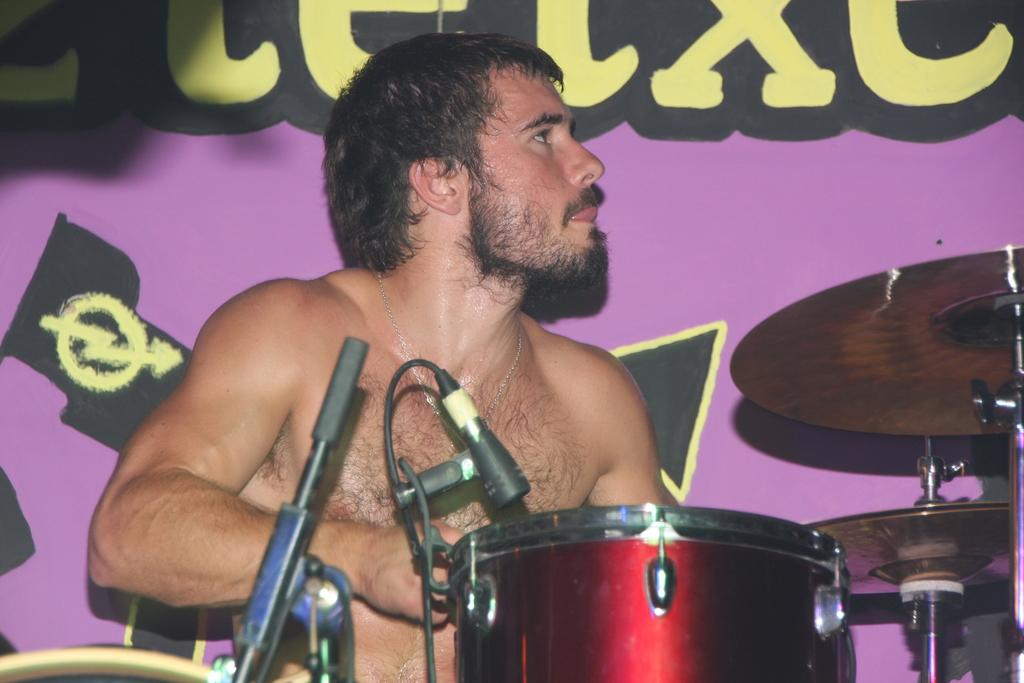What is the main subject of the image? The main subject of the image is a man. In which direction is the man looking? The man is looking to the right side. What is the man doing in the image? The man is playing a musical instrument. What type of power source is visible in the image? There is no power source visible in the image; it features a man playing a musical instrument. What type of linen fabric is draped over the man's shoulder in the image? There is no linen fabric visible in the image. What type of stem can be seen growing from the man's instrument in the image? There is no stem visible in the image; the man is playing a musical instrument, but it does not have any visible stems. 